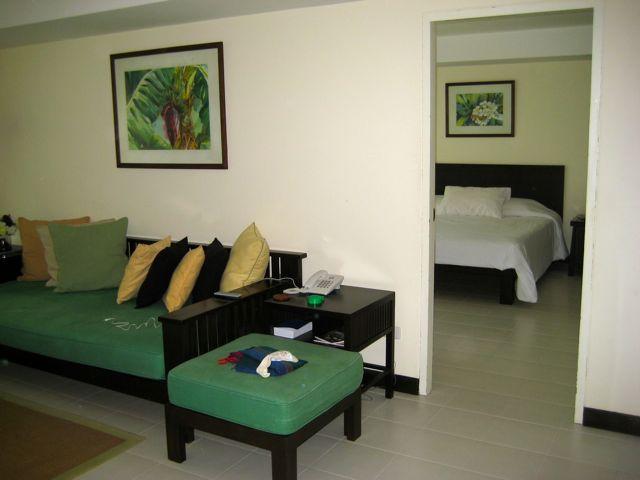What is on the ottoman?
Write a very short answer. Clothes. How many cushions does the couch in the picture have?
Short answer required. 8. Is this a kitchen?
Give a very brief answer. No. Is there anyone pictured in this scene?
Be succinct. No. What items are located on the table?
Quick response, please. Phone. What would the open item on the couch be used for?
Quick response, please. Listening. 